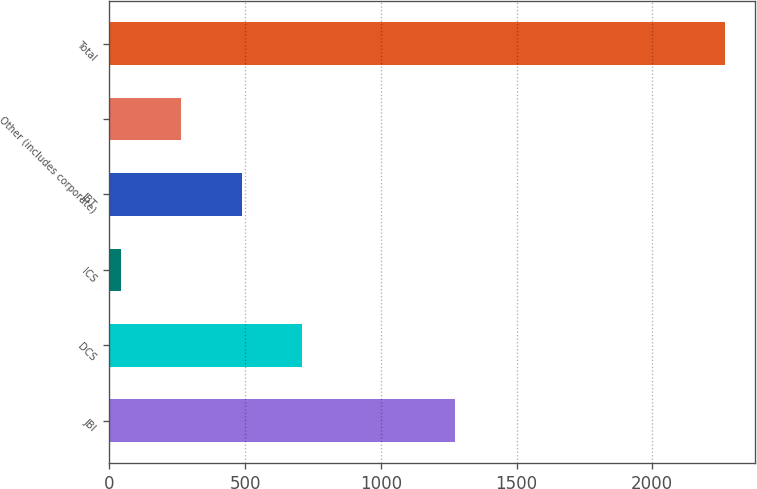Convert chart to OTSL. <chart><loc_0><loc_0><loc_500><loc_500><bar_chart><fcel>JBI<fcel>DCS<fcel>ICS<fcel>JBT<fcel>Other (includes corporate)<fcel>Total<nl><fcel>1273<fcel>709.5<fcel>42<fcel>487<fcel>264.5<fcel>2267<nl></chart> 